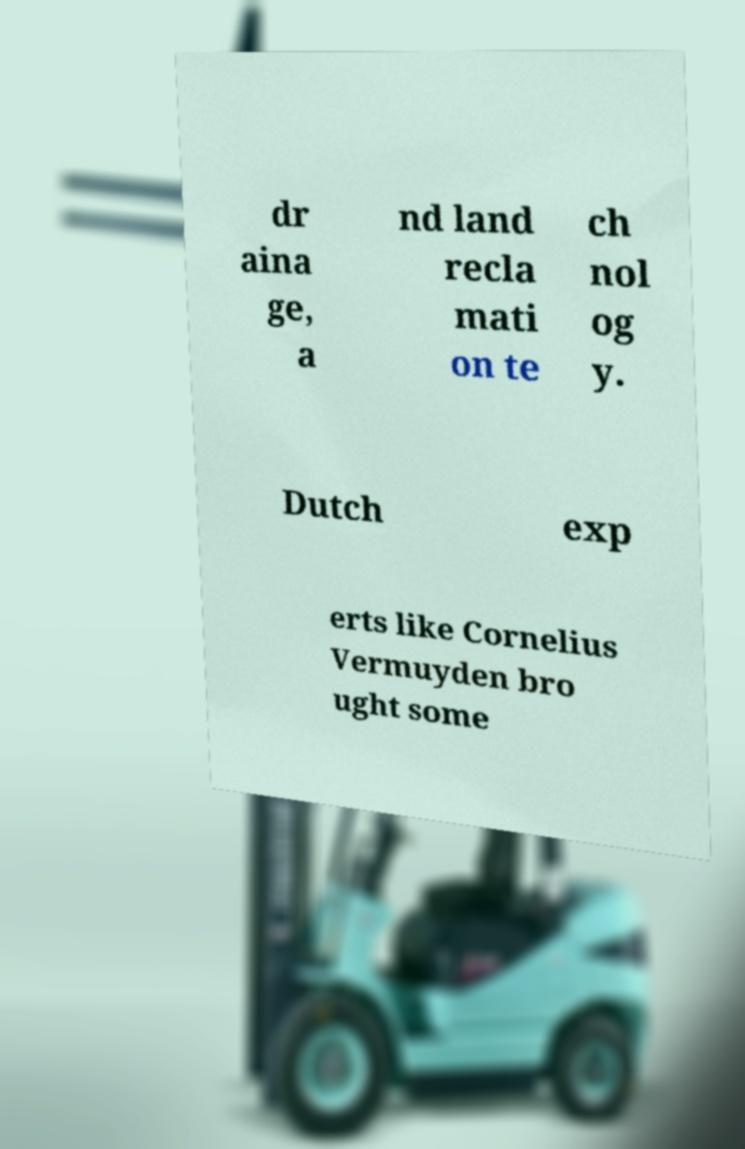I need the written content from this picture converted into text. Can you do that? dr aina ge, a nd land recla mati on te ch nol og y. Dutch exp erts like Cornelius Vermuyden bro ught some 